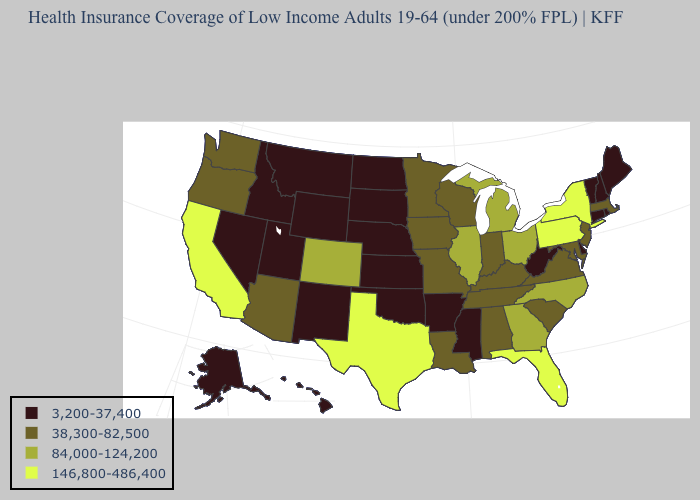Name the states that have a value in the range 38,300-82,500?
Write a very short answer. Alabama, Arizona, Indiana, Iowa, Kentucky, Louisiana, Maryland, Massachusetts, Minnesota, Missouri, New Jersey, Oregon, South Carolina, Tennessee, Virginia, Washington, Wisconsin. Among the states that border Nevada , does California have the highest value?
Short answer required. Yes. Does the first symbol in the legend represent the smallest category?
Write a very short answer. Yes. Does the map have missing data?
Keep it brief. No. Does Hawaii have the lowest value in the USA?
Give a very brief answer. Yes. Among the states that border Tennessee , which have the highest value?
Be succinct. Georgia, North Carolina. What is the value of Virginia?
Quick response, please. 38,300-82,500. Name the states that have a value in the range 146,800-486,400?
Short answer required. California, Florida, New York, Pennsylvania, Texas. Name the states that have a value in the range 146,800-486,400?
Answer briefly. California, Florida, New York, Pennsylvania, Texas. What is the lowest value in the USA?
Give a very brief answer. 3,200-37,400. What is the value of New Mexico?
Short answer required. 3,200-37,400. Name the states that have a value in the range 146,800-486,400?
Quick response, please. California, Florida, New York, Pennsylvania, Texas. What is the value of Colorado?
Short answer required. 84,000-124,200. Does Oregon have the highest value in the USA?
Concise answer only. No. Name the states that have a value in the range 84,000-124,200?
Keep it brief. Colorado, Georgia, Illinois, Michigan, North Carolina, Ohio. 